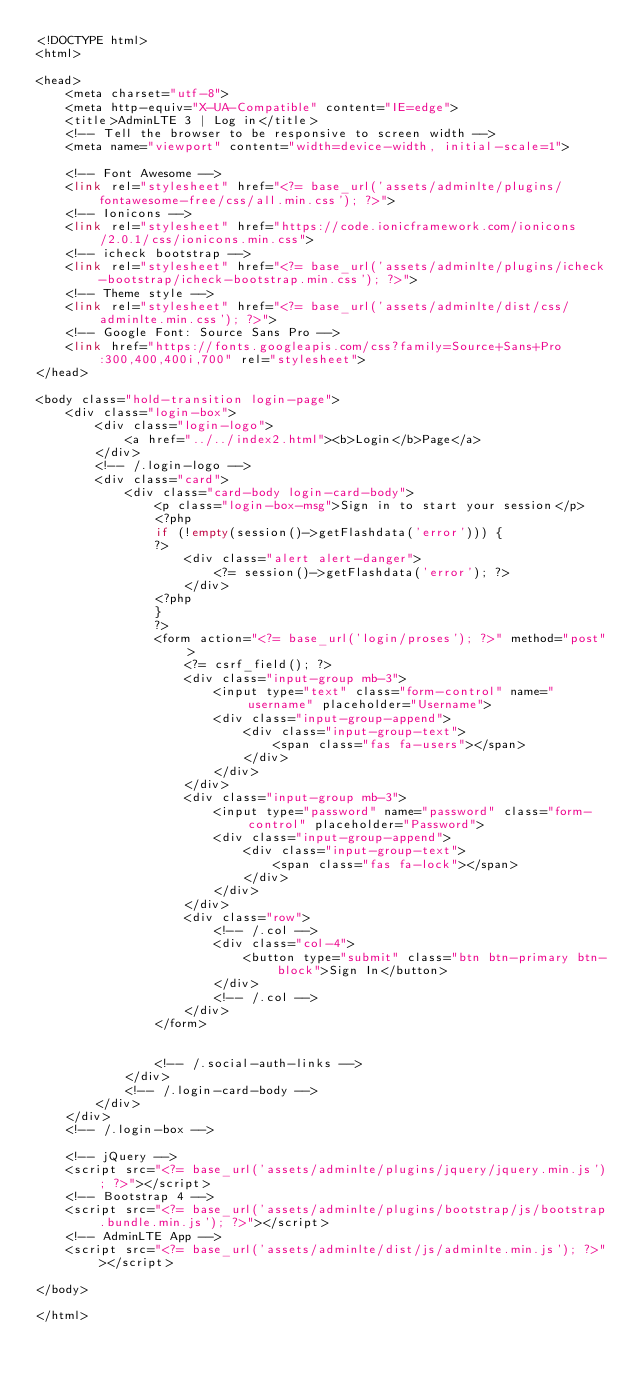Convert code to text. <code><loc_0><loc_0><loc_500><loc_500><_PHP_><!DOCTYPE html>
<html>

<head>
    <meta charset="utf-8">
    <meta http-equiv="X-UA-Compatible" content="IE=edge">
    <title>AdminLTE 3 | Log in</title>
    <!-- Tell the browser to be responsive to screen width -->
    <meta name="viewport" content="width=device-width, initial-scale=1">

    <!-- Font Awesome -->
    <link rel="stylesheet" href="<?= base_url('assets/adminlte/plugins/fontawesome-free/css/all.min.css'); ?>">
    <!-- Ionicons -->
    <link rel="stylesheet" href="https://code.ionicframework.com/ionicons/2.0.1/css/ionicons.min.css">
    <!-- icheck bootstrap -->
    <link rel="stylesheet" href="<?= base_url('assets/adminlte/plugins/icheck-bootstrap/icheck-bootstrap.min.css'); ?>">
    <!-- Theme style -->
    <link rel="stylesheet" href="<?= base_url('assets/adminlte/dist/css/adminlte.min.css'); ?>">
    <!-- Google Font: Source Sans Pro -->
    <link href="https://fonts.googleapis.com/css?family=Source+Sans+Pro:300,400,400i,700" rel="stylesheet">
</head>

<body class="hold-transition login-page">
    <div class="login-box">
        <div class="login-logo">
            <a href="../../index2.html"><b>Login</b>Page</a>
        </div>
        <!-- /.login-logo -->
        <div class="card">
            <div class="card-body login-card-body">
                <p class="login-box-msg">Sign in to start your session</p>
                <?php
                if (!empty(session()->getFlashdata('error'))) {
                ?>
                    <div class="alert alert-danger">
                        <?= session()->getFlashdata('error'); ?>
                    </div>
                <?php
                }
                ?>
                <form action="<?= base_url('login/proses'); ?>" method="post">
                    <?= csrf_field(); ?>
                    <div class="input-group mb-3">
                        <input type="text" class="form-control" name="username" placeholder="Username">
                        <div class="input-group-append">
                            <div class="input-group-text">
                                <span class="fas fa-users"></span>
                            </div>
                        </div>
                    </div>
                    <div class="input-group mb-3">
                        <input type="password" name="password" class="form-control" placeholder="Password">
                        <div class="input-group-append">
                            <div class="input-group-text">
                                <span class="fas fa-lock"></span>
                            </div>
                        </div>
                    </div>
                    <div class="row">
                        <!-- /.col -->
                        <div class="col-4">
                            <button type="submit" class="btn btn-primary btn-block">Sign In</button>
                        </div>
                        <!-- /.col -->
                    </div>
                </form>


                <!-- /.social-auth-links -->
            </div>
            <!-- /.login-card-body -->
        </div>
    </div>
    <!-- /.login-box -->

    <!-- jQuery -->
    <script src="<?= base_url('assets/adminlte/plugins/jquery/jquery.min.js'); ?>"></script>
    <!-- Bootstrap 4 -->
    <script src="<?= base_url('assets/adminlte/plugins/bootstrap/js/bootstrap.bundle.min.js'); ?>"></script>
    <!-- AdminLTE App -->
    <script src="<?= base_url('assets/adminlte/dist/js/adminlte.min.js'); ?>"></script>

</body>

</html></code> 